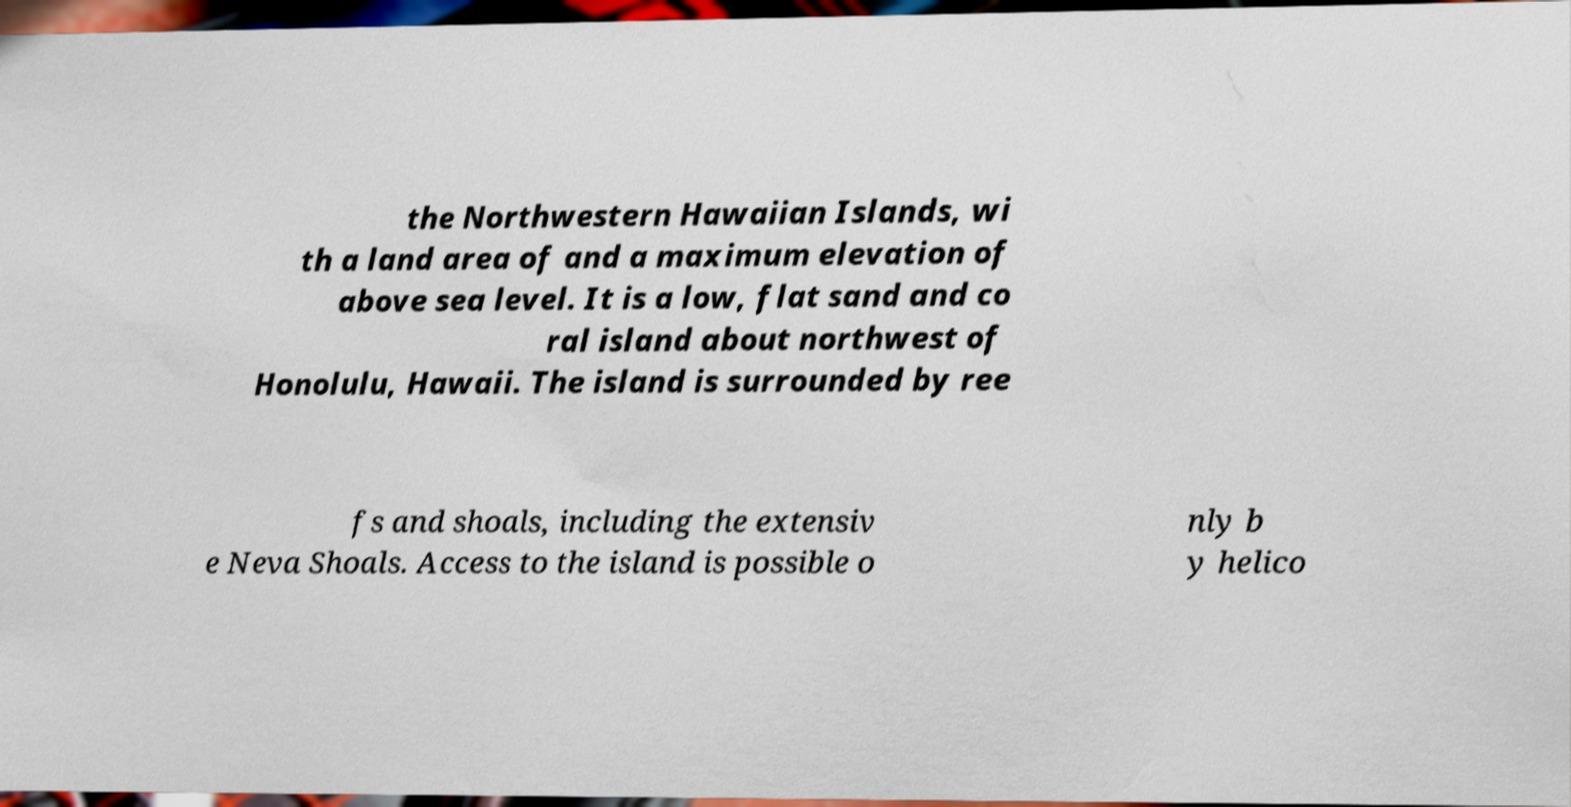Please read and relay the text visible in this image. What does it say? the Northwestern Hawaiian Islands, wi th a land area of and a maximum elevation of above sea level. It is a low, flat sand and co ral island about northwest of Honolulu, Hawaii. The island is surrounded by ree fs and shoals, including the extensiv e Neva Shoals. Access to the island is possible o nly b y helico 